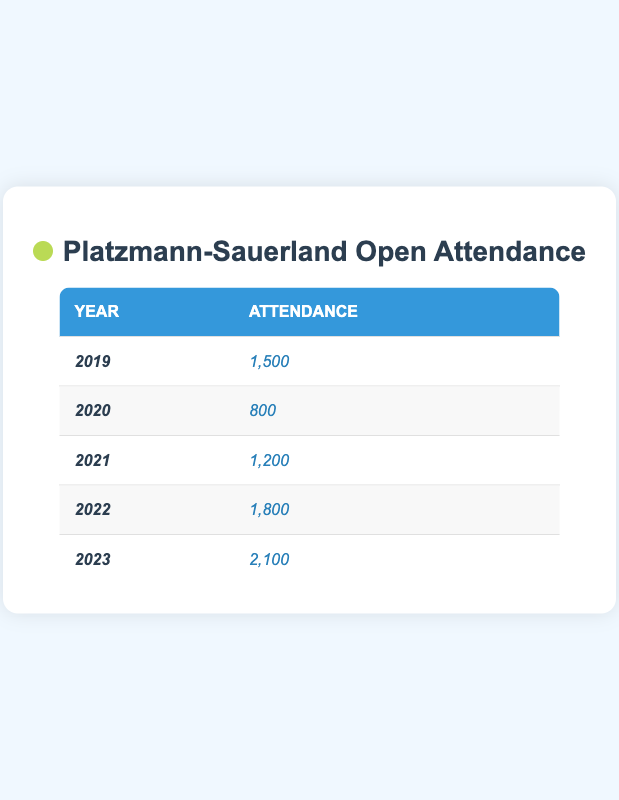What was the attendance in 2020? The table shows that in the year 2020, the attendance figure is listed as 800.
Answer: 800 Which year had the highest attendance? By examining the attendance figures for each year, 2023 has the highest attendance of 2,100.
Answer: 2023 What is the difference in attendance between 2022 and 2021? The attendance for 2022 is 1,800 and for 2021 is 1,200. The difference is 1,800 - 1,200 = 600.
Answer: 600 Was the attendance in 2021 greater than in 2019? The attendance in 2021 is 1,200, while in 2019 it was 1,500. Since 1,200 is less than 1,500, the answer is no.
Answer: No What is the average attendance over these five years? To find the average, sum the attendance figures: 1,500 + 800 + 1,200 + 1,800 + 2,100 = 7,400. Divide by the number of years (5), so 7,400 / 5 = 1,480.
Answer: 1,480 In which year was the attendance less than 1,000? By looking through the attendance figures, only the year 2020 has attendance below 1,000, at 800.
Answer: 2020 How much did the attendance increase from 2019 to 2023? The attendance in 2019 was 1,500 and in 2023 it was 2,100. The increase is 2,100 - 1,500 = 600.
Answer: 600 Has the attendance consistently increased each year from 2019 to 2023? Reviewing the data, attendance for each year is: 2019 (1,500), 2020 (800), 2021 (1,200), 2022 (1,800), 2023 (2,100). There's a drop in 2020, so attendance was not consistent.
Answer: No What was the total attendance for the years 2021 and 2022 combined? The attendance for 2021 is 1,200 and for 2022 is 1,800, so the total is 1,200 + 1,800 = 3,000.
Answer: 3,000 Which years had attendance figures greater than 1,500? From the table, the years with attendance greater than 1,500 are 2022 (1,800) and 2023 (2,100).
Answer: 2022, 2023 